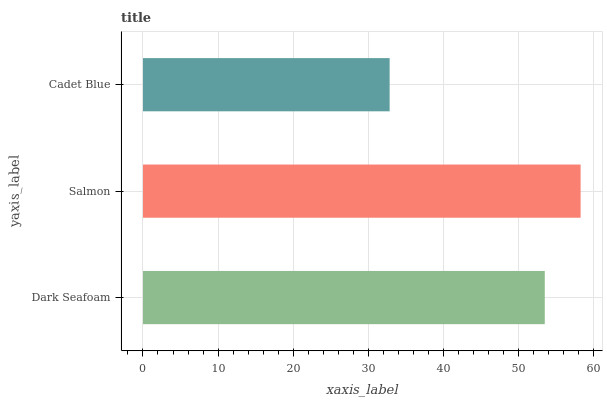Is Cadet Blue the minimum?
Answer yes or no. Yes. Is Salmon the maximum?
Answer yes or no. Yes. Is Salmon the minimum?
Answer yes or no. No. Is Cadet Blue the maximum?
Answer yes or no. No. Is Salmon greater than Cadet Blue?
Answer yes or no. Yes. Is Cadet Blue less than Salmon?
Answer yes or no. Yes. Is Cadet Blue greater than Salmon?
Answer yes or no. No. Is Salmon less than Cadet Blue?
Answer yes or no. No. Is Dark Seafoam the high median?
Answer yes or no. Yes. Is Dark Seafoam the low median?
Answer yes or no. Yes. Is Cadet Blue the high median?
Answer yes or no. No. Is Cadet Blue the low median?
Answer yes or no. No. 